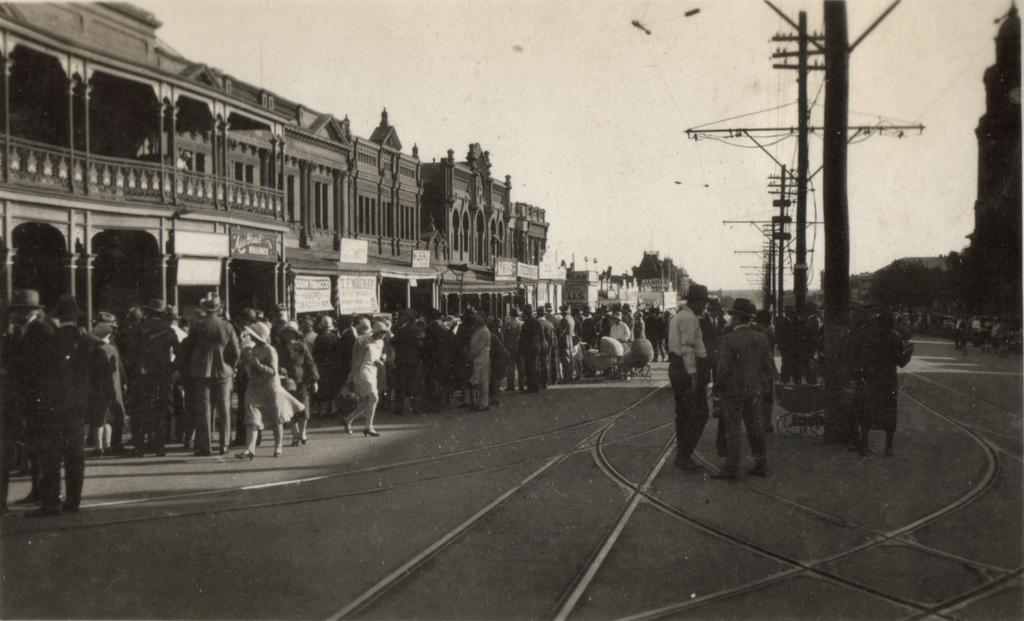Could you give a brief overview of what you see in this image? It is an old black and white picture, there is a crowd standing around the road and on the left side there are some buildings and on the right side there are current polls in between the road. 